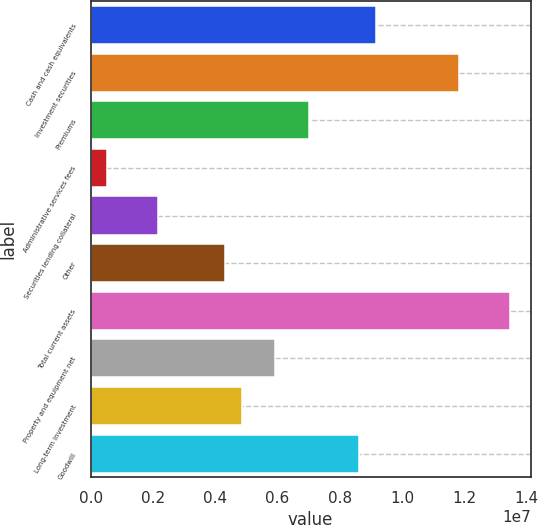Convert chart. <chart><loc_0><loc_0><loc_500><loc_500><bar_chart><fcel>Cash and cash equivalents<fcel>Investment securities<fcel>Premiums<fcel>Administrative services fees<fcel>Securities lending collateral<fcel>Other<fcel>Total current assets<fcel>Property and equipment net<fcel>Long-term investment<fcel>Goodwill<nl><fcel>9.14516e+06<fcel>1.18347e+07<fcel>6.99353e+06<fcel>538660<fcel>2.15238e+06<fcel>4.304e+06<fcel>1.34484e+07<fcel>5.91772e+06<fcel>4.84191e+06<fcel>8.60725e+06<nl></chart> 